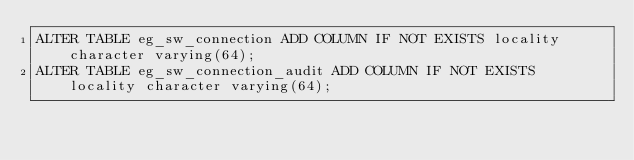Convert code to text. <code><loc_0><loc_0><loc_500><loc_500><_SQL_>ALTER TABLE eg_sw_connection ADD COLUMN IF NOT EXISTS locality character varying(64);
ALTER TABLE eg_sw_connection_audit ADD COLUMN IF NOT EXISTS locality character varying(64);</code> 